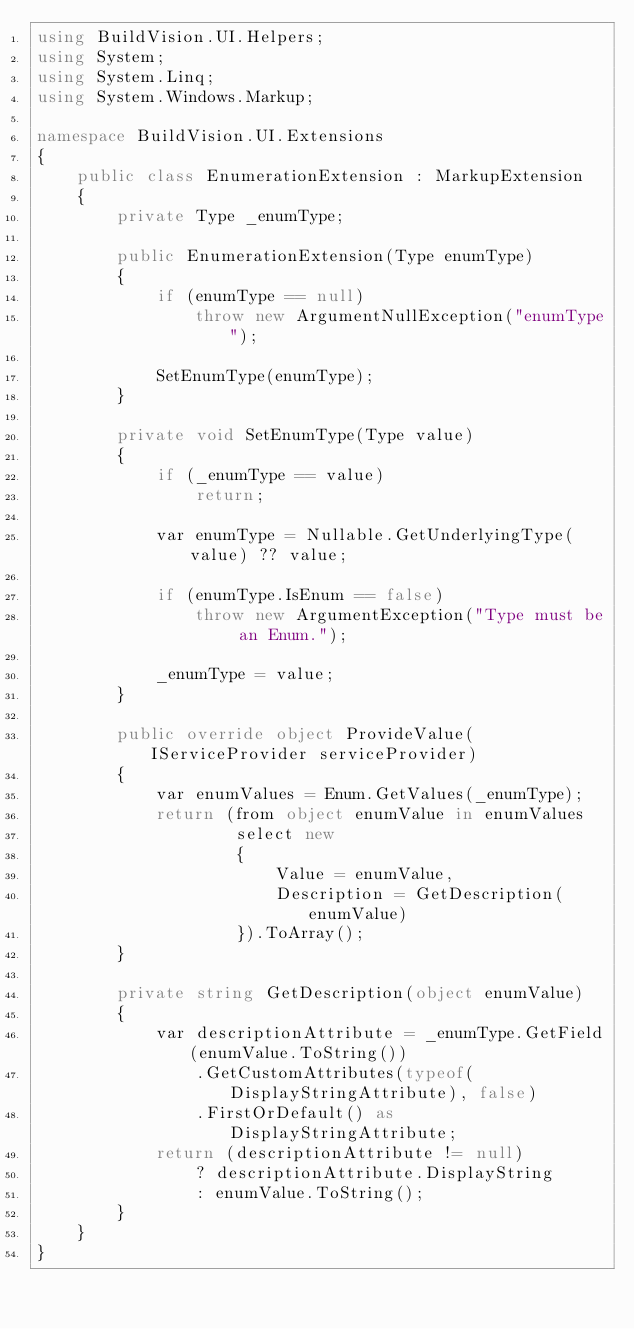<code> <loc_0><loc_0><loc_500><loc_500><_C#_>using BuildVision.UI.Helpers;
using System;
using System.Linq;
using System.Windows.Markup;

namespace BuildVision.UI.Extensions
{
    public class EnumerationExtension : MarkupExtension
    {
        private Type _enumType;

        public EnumerationExtension(Type enumType)
        {
            if (enumType == null)
                throw new ArgumentNullException("enumType");

            SetEnumType(enumType);
        }

        private void SetEnumType(Type value)
        {
            if (_enumType == value)
                return;

            var enumType = Nullable.GetUnderlyingType(value) ?? value;

            if (enumType.IsEnum == false)
                throw new ArgumentException("Type must be an Enum.");

            _enumType = value;
        }

        public override object ProvideValue(IServiceProvider serviceProvider)
        {
            var enumValues = Enum.GetValues(_enumType);
            return (from object enumValue in enumValues
                    select new
                    {
                        Value = enumValue,
                        Description = GetDescription(enumValue)
                    }).ToArray();
        }

        private string GetDescription(object enumValue)
        {
            var descriptionAttribute = _enumType.GetField(enumValue.ToString())
                .GetCustomAttributes(typeof(DisplayStringAttribute), false)
                .FirstOrDefault() as DisplayStringAttribute;
            return (descriptionAttribute != null)
                ? descriptionAttribute.DisplayString
                : enumValue.ToString();
        }
    }
}</code> 